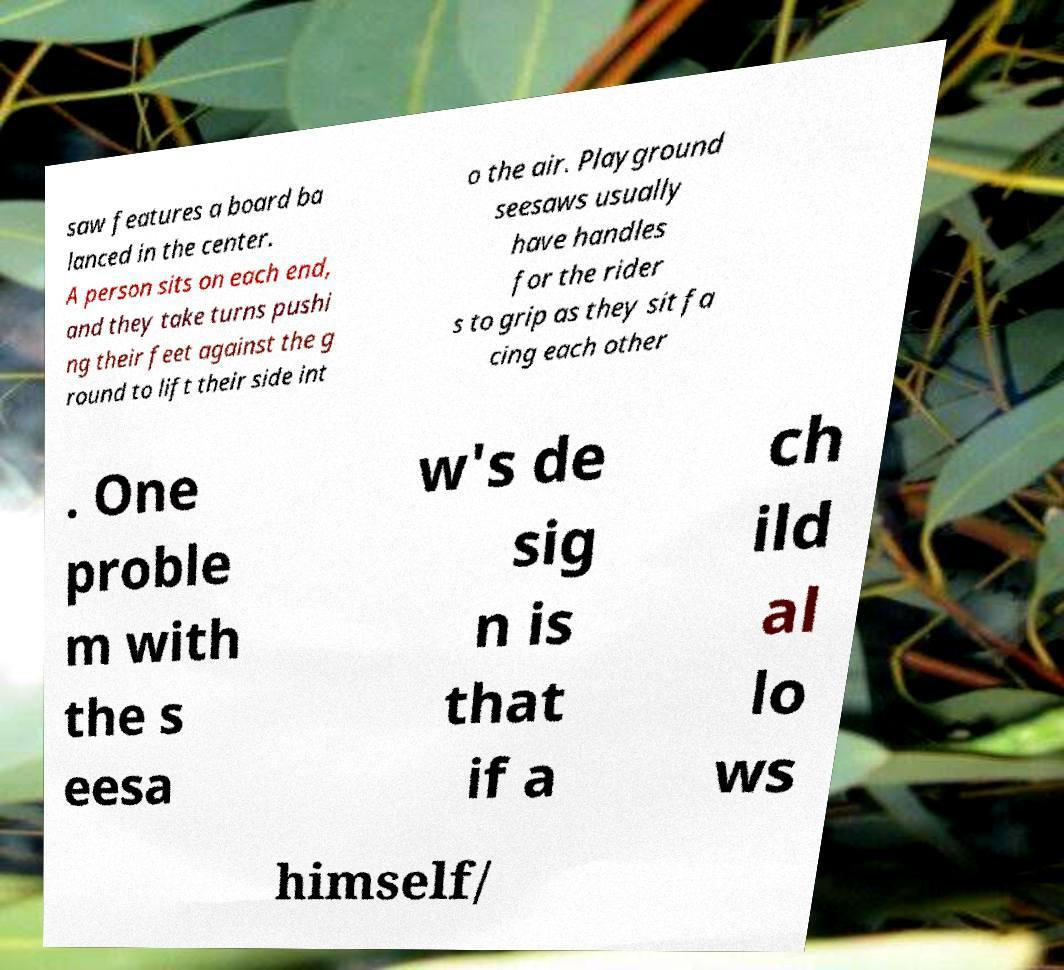Could you assist in decoding the text presented in this image and type it out clearly? saw features a board ba lanced in the center. A person sits on each end, and they take turns pushi ng their feet against the g round to lift their side int o the air. Playground seesaws usually have handles for the rider s to grip as they sit fa cing each other . One proble m with the s eesa w's de sig n is that if a ch ild al lo ws himself/ 